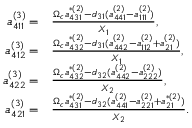Convert formula to latex. <formula><loc_0><loc_0><loc_500><loc_500>\begin{array} { r l } { a _ { 4 1 1 } ^ { ( 3 ) } = } & \frac { \Omega _ { c } a _ { 4 3 1 } ^ { \ast ( 2 ) } - d _ { 3 1 } ( a _ { 4 4 1 } ^ { ( 2 ) } - a _ { 1 1 1 } ^ { ( 2 ) } ) } { X _ { 1 } } , } \\ { a _ { 4 1 2 } ^ { ( 3 ) } = } & \frac { \Omega _ { c } a _ { 4 3 2 } ^ { \ast ( 2 ) } - d _ { 3 1 } ( a _ { 4 4 2 } ^ { ( 2 ) } - a _ { 1 1 2 } ^ { ( 2 ) } + a _ { 2 1 } ^ { ( 2 ) } ) } { X _ { 1 } } , } \\ { a _ { 4 2 2 } ^ { ( 3 ) } = } & \frac { \Omega _ { c } a _ { 4 3 2 } ^ { \ast ( 2 ) } - d _ { 3 2 } ( a _ { 4 4 2 } ^ { ( 2 ) } - a _ { 2 2 2 } ^ { ( 2 ) } ) } { X _ { 2 } } , } \\ { a _ { 4 2 1 } ^ { ( 3 ) } = } & \frac { \Omega _ { c } a _ { 4 3 1 } ^ { \ast ( 2 ) } - d _ { 3 2 } ( a _ { 4 4 1 } ^ { ( 2 ) } - a _ { 2 2 1 } ^ { ( 2 ) } + a _ { 2 1 } ^ { \ast ( 2 ) } ) } { X _ { 2 } } . } \end{array}</formula> 